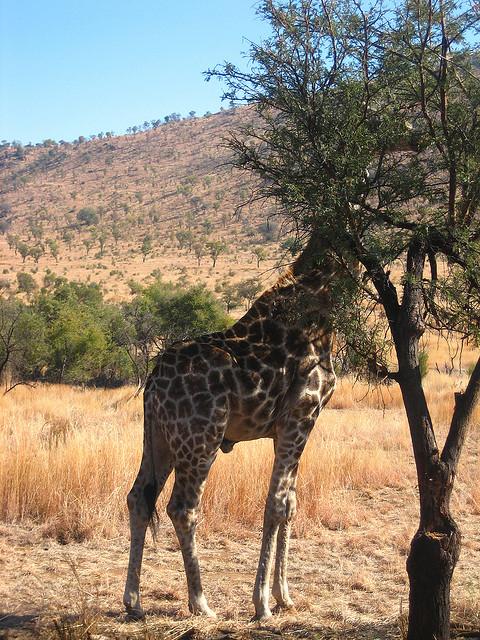Where does it look like the giraffe lives?
Write a very short answer. Africa. Is the animal as tall as the tree trunk?
Be succinct. Yes. What climate is the giraffe located in?
Keep it brief. Warm. Is this animal in a zoo?
Write a very short answer. No. 